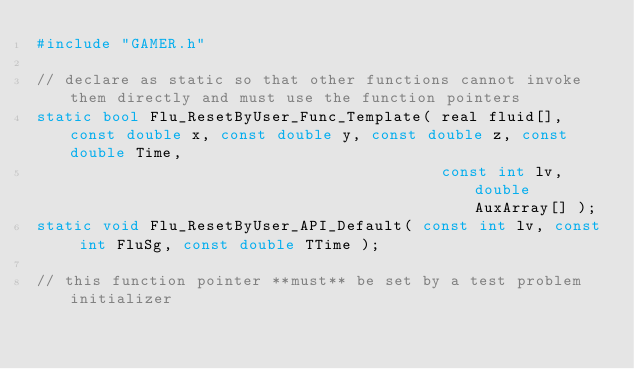Convert code to text. <code><loc_0><loc_0><loc_500><loc_500><_C++_>#include "GAMER.h"

// declare as static so that other functions cannot invoke them directly and must use the function pointers
static bool Flu_ResetByUser_Func_Template( real fluid[], const double x, const double y, const double z, const double Time,
                                           const int lv, double AuxArray[] );
static void Flu_ResetByUser_API_Default( const int lv, const int FluSg, const double TTime );

// this function pointer **must** be set by a test problem initializer</code> 